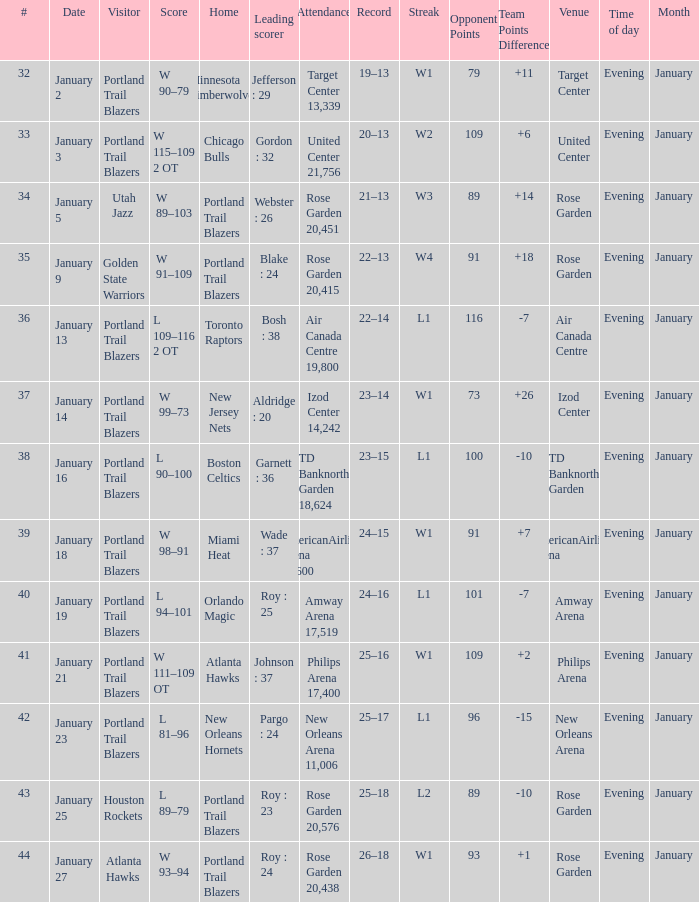Who are all the visitor with a record of 25–18 Houston Rockets. 